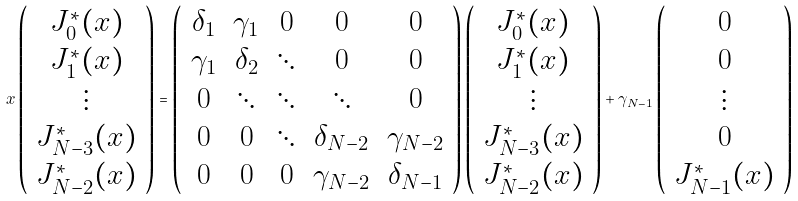<formula> <loc_0><loc_0><loc_500><loc_500>x \left ( \begin{array} { c } J _ { 0 } ^ { * } ( x ) \\ J _ { 1 } ^ { * } ( x ) \\ \vdots \\ J _ { N - 3 } ^ { * } ( x ) \\ J _ { N - 2 } ^ { * } ( x ) \end{array} \right ) = \left ( \begin{array} { c c c c c } \delta _ { 1 } & \gamma _ { 1 } & 0 & 0 & 0 \\ \gamma _ { 1 } & \delta _ { 2 } & \ddots & 0 & 0 \\ 0 & \ddots & \ddots & \ddots & 0 \\ 0 & 0 & \ddots & \delta _ { N - 2 } & \gamma _ { N - 2 } \\ 0 & 0 & 0 & \gamma _ { N - 2 } & \delta _ { N - 1 } \end{array} \right ) \left ( \begin{array} { c } J _ { 0 } ^ { * } ( x ) \\ J _ { 1 } ^ { * } ( x ) \\ \vdots \\ J _ { N - 3 } ^ { * } ( x ) \\ J _ { N - 2 } ^ { * } ( x ) \end{array} \right ) + \gamma _ { N - 1 } \left ( \begin{array} { c } 0 \\ 0 \\ \vdots \\ 0 \\ J _ { N - 1 } ^ { * } ( x ) \end{array} \right )</formula> 